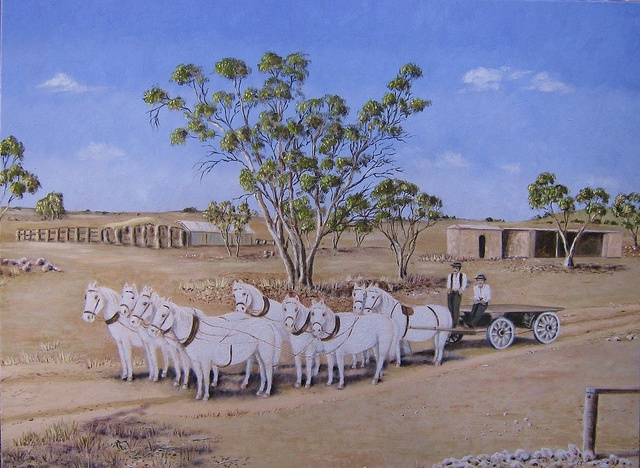Describe the objects in this image and their specific colors. I can see horse in purple, darkgray, gray, and lavender tones, horse in purple, darkgray, and gray tones, horse in purple, darkgray, and gray tones, horse in purple, darkgray, and lavender tones, and horse in purple, darkgray, and gray tones in this image. 